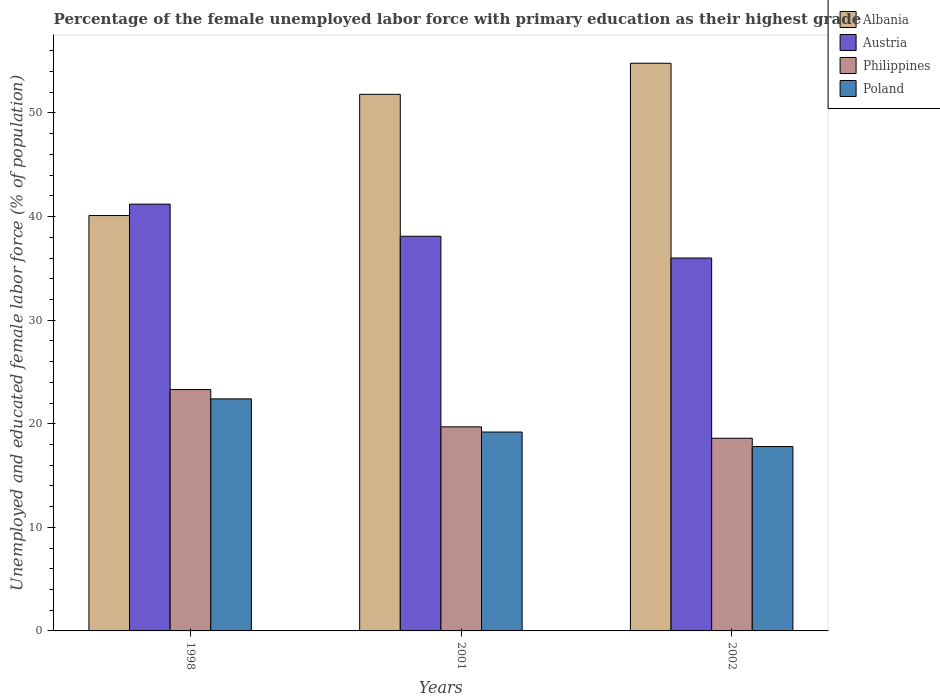How many different coloured bars are there?
Offer a very short reply. 4. How many bars are there on the 2nd tick from the left?
Provide a short and direct response. 4. How many bars are there on the 2nd tick from the right?
Provide a succinct answer. 4. In how many cases, is the number of bars for a given year not equal to the number of legend labels?
Ensure brevity in your answer.  0. What is the percentage of the unemployed female labor force with primary education in Poland in 1998?
Provide a short and direct response. 22.4. Across all years, what is the maximum percentage of the unemployed female labor force with primary education in Philippines?
Your answer should be compact. 23.3. Across all years, what is the minimum percentage of the unemployed female labor force with primary education in Philippines?
Provide a short and direct response. 18.6. In which year was the percentage of the unemployed female labor force with primary education in Albania minimum?
Provide a succinct answer. 1998. What is the total percentage of the unemployed female labor force with primary education in Austria in the graph?
Keep it short and to the point. 115.3. What is the difference between the percentage of the unemployed female labor force with primary education in Philippines in 1998 and that in 2002?
Ensure brevity in your answer.  4.7. What is the difference between the percentage of the unemployed female labor force with primary education in Philippines in 1998 and the percentage of the unemployed female labor force with primary education in Albania in 2001?
Keep it short and to the point. -28.5. What is the average percentage of the unemployed female labor force with primary education in Albania per year?
Ensure brevity in your answer.  48.9. In the year 2001, what is the difference between the percentage of the unemployed female labor force with primary education in Albania and percentage of the unemployed female labor force with primary education in Philippines?
Offer a terse response. 32.1. In how many years, is the percentage of the unemployed female labor force with primary education in Austria greater than 6 %?
Provide a short and direct response. 3. What is the ratio of the percentage of the unemployed female labor force with primary education in Albania in 1998 to that in 2002?
Keep it short and to the point. 0.73. What is the difference between the highest and the second highest percentage of the unemployed female labor force with primary education in Albania?
Give a very brief answer. 3. What is the difference between the highest and the lowest percentage of the unemployed female labor force with primary education in Philippines?
Provide a succinct answer. 4.7. Is the sum of the percentage of the unemployed female labor force with primary education in Albania in 1998 and 2002 greater than the maximum percentage of the unemployed female labor force with primary education in Poland across all years?
Give a very brief answer. Yes. Is it the case that in every year, the sum of the percentage of the unemployed female labor force with primary education in Poland and percentage of the unemployed female labor force with primary education in Albania is greater than the sum of percentage of the unemployed female labor force with primary education in Austria and percentage of the unemployed female labor force with primary education in Philippines?
Provide a succinct answer. Yes. What does the 1st bar from the left in 1998 represents?
Your answer should be compact. Albania. What does the 2nd bar from the right in 2001 represents?
Provide a short and direct response. Philippines. How many bars are there?
Keep it short and to the point. 12. How many years are there in the graph?
Offer a terse response. 3. Does the graph contain grids?
Your response must be concise. No. Where does the legend appear in the graph?
Your answer should be compact. Top right. What is the title of the graph?
Provide a succinct answer. Percentage of the female unemployed labor force with primary education as their highest grade. Does "Peru" appear as one of the legend labels in the graph?
Your answer should be compact. No. What is the label or title of the X-axis?
Your answer should be very brief. Years. What is the label or title of the Y-axis?
Your answer should be very brief. Unemployed and educated female labor force (% of population). What is the Unemployed and educated female labor force (% of population) of Albania in 1998?
Provide a short and direct response. 40.1. What is the Unemployed and educated female labor force (% of population) of Austria in 1998?
Make the answer very short. 41.2. What is the Unemployed and educated female labor force (% of population) in Philippines in 1998?
Your answer should be compact. 23.3. What is the Unemployed and educated female labor force (% of population) in Poland in 1998?
Offer a very short reply. 22.4. What is the Unemployed and educated female labor force (% of population) of Albania in 2001?
Make the answer very short. 51.8. What is the Unemployed and educated female labor force (% of population) in Austria in 2001?
Keep it short and to the point. 38.1. What is the Unemployed and educated female labor force (% of population) in Philippines in 2001?
Offer a terse response. 19.7. What is the Unemployed and educated female labor force (% of population) in Poland in 2001?
Offer a terse response. 19.2. What is the Unemployed and educated female labor force (% of population) of Albania in 2002?
Ensure brevity in your answer.  54.8. What is the Unemployed and educated female labor force (% of population) of Austria in 2002?
Offer a terse response. 36. What is the Unemployed and educated female labor force (% of population) of Philippines in 2002?
Your answer should be very brief. 18.6. What is the Unemployed and educated female labor force (% of population) of Poland in 2002?
Keep it short and to the point. 17.8. Across all years, what is the maximum Unemployed and educated female labor force (% of population) in Albania?
Your response must be concise. 54.8. Across all years, what is the maximum Unemployed and educated female labor force (% of population) of Austria?
Ensure brevity in your answer.  41.2. Across all years, what is the maximum Unemployed and educated female labor force (% of population) of Philippines?
Provide a succinct answer. 23.3. Across all years, what is the maximum Unemployed and educated female labor force (% of population) of Poland?
Offer a very short reply. 22.4. Across all years, what is the minimum Unemployed and educated female labor force (% of population) of Albania?
Keep it short and to the point. 40.1. Across all years, what is the minimum Unemployed and educated female labor force (% of population) of Philippines?
Give a very brief answer. 18.6. Across all years, what is the minimum Unemployed and educated female labor force (% of population) in Poland?
Keep it short and to the point. 17.8. What is the total Unemployed and educated female labor force (% of population) of Albania in the graph?
Your answer should be compact. 146.7. What is the total Unemployed and educated female labor force (% of population) of Austria in the graph?
Provide a succinct answer. 115.3. What is the total Unemployed and educated female labor force (% of population) in Philippines in the graph?
Your answer should be compact. 61.6. What is the total Unemployed and educated female labor force (% of population) of Poland in the graph?
Your answer should be compact. 59.4. What is the difference between the Unemployed and educated female labor force (% of population) of Albania in 1998 and that in 2001?
Offer a very short reply. -11.7. What is the difference between the Unemployed and educated female labor force (% of population) in Austria in 1998 and that in 2001?
Offer a very short reply. 3.1. What is the difference between the Unemployed and educated female labor force (% of population) of Philippines in 1998 and that in 2001?
Offer a terse response. 3.6. What is the difference between the Unemployed and educated female labor force (% of population) of Albania in 1998 and that in 2002?
Make the answer very short. -14.7. What is the difference between the Unemployed and educated female labor force (% of population) in Philippines in 1998 and that in 2002?
Offer a very short reply. 4.7. What is the difference between the Unemployed and educated female labor force (% of population) in Poland in 1998 and that in 2002?
Your answer should be very brief. 4.6. What is the difference between the Unemployed and educated female labor force (% of population) of Austria in 2001 and that in 2002?
Make the answer very short. 2.1. What is the difference between the Unemployed and educated female labor force (% of population) of Poland in 2001 and that in 2002?
Provide a short and direct response. 1.4. What is the difference between the Unemployed and educated female labor force (% of population) of Albania in 1998 and the Unemployed and educated female labor force (% of population) of Austria in 2001?
Provide a short and direct response. 2. What is the difference between the Unemployed and educated female labor force (% of population) of Albania in 1998 and the Unemployed and educated female labor force (% of population) of Philippines in 2001?
Keep it short and to the point. 20.4. What is the difference between the Unemployed and educated female labor force (% of population) of Albania in 1998 and the Unemployed and educated female labor force (% of population) of Poland in 2001?
Your answer should be very brief. 20.9. What is the difference between the Unemployed and educated female labor force (% of population) of Austria in 1998 and the Unemployed and educated female labor force (% of population) of Philippines in 2001?
Provide a succinct answer. 21.5. What is the difference between the Unemployed and educated female labor force (% of population) in Albania in 1998 and the Unemployed and educated female labor force (% of population) in Philippines in 2002?
Make the answer very short. 21.5. What is the difference between the Unemployed and educated female labor force (% of population) of Albania in 1998 and the Unemployed and educated female labor force (% of population) of Poland in 2002?
Keep it short and to the point. 22.3. What is the difference between the Unemployed and educated female labor force (% of population) of Austria in 1998 and the Unemployed and educated female labor force (% of population) of Philippines in 2002?
Your response must be concise. 22.6. What is the difference between the Unemployed and educated female labor force (% of population) in Austria in 1998 and the Unemployed and educated female labor force (% of population) in Poland in 2002?
Keep it short and to the point. 23.4. What is the difference between the Unemployed and educated female labor force (% of population) in Philippines in 1998 and the Unemployed and educated female labor force (% of population) in Poland in 2002?
Your answer should be very brief. 5.5. What is the difference between the Unemployed and educated female labor force (% of population) of Albania in 2001 and the Unemployed and educated female labor force (% of population) of Philippines in 2002?
Keep it short and to the point. 33.2. What is the difference between the Unemployed and educated female labor force (% of population) in Albania in 2001 and the Unemployed and educated female labor force (% of population) in Poland in 2002?
Offer a very short reply. 34. What is the difference between the Unemployed and educated female labor force (% of population) of Austria in 2001 and the Unemployed and educated female labor force (% of population) of Poland in 2002?
Provide a succinct answer. 20.3. What is the difference between the Unemployed and educated female labor force (% of population) of Philippines in 2001 and the Unemployed and educated female labor force (% of population) of Poland in 2002?
Make the answer very short. 1.9. What is the average Unemployed and educated female labor force (% of population) of Albania per year?
Keep it short and to the point. 48.9. What is the average Unemployed and educated female labor force (% of population) of Austria per year?
Keep it short and to the point. 38.43. What is the average Unemployed and educated female labor force (% of population) in Philippines per year?
Your response must be concise. 20.53. What is the average Unemployed and educated female labor force (% of population) of Poland per year?
Provide a short and direct response. 19.8. In the year 1998, what is the difference between the Unemployed and educated female labor force (% of population) in Albania and Unemployed and educated female labor force (% of population) in Philippines?
Ensure brevity in your answer.  16.8. In the year 1998, what is the difference between the Unemployed and educated female labor force (% of population) in Albania and Unemployed and educated female labor force (% of population) in Poland?
Your response must be concise. 17.7. In the year 1998, what is the difference between the Unemployed and educated female labor force (% of population) of Austria and Unemployed and educated female labor force (% of population) of Philippines?
Give a very brief answer. 17.9. In the year 1998, what is the difference between the Unemployed and educated female labor force (% of population) of Philippines and Unemployed and educated female labor force (% of population) of Poland?
Your response must be concise. 0.9. In the year 2001, what is the difference between the Unemployed and educated female labor force (% of population) in Albania and Unemployed and educated female labor force (% of population) in Austria?
Your response must be concise. 13.7. In the year 2001, what is the difference between the Unemployed and educated female labor force (% of population) of Albania and Unemployed and educated female labor force (% of population) of Philippines?
Provide a succinct answer. 32.1. In the year 2001, what is the difference between the Unemployed and educated female labor force (% of population) in Albania and Unemployed and educated female labor force (% of population) in Poland?
Your response must be concise. 32.6. In the year 2001, what is the difference between the Unemployed and educated female labor force (% of population) of Philippines and Unemployed and educated female labor force (% of population) of Poland?
Provide a succinct answer. 0.5. In the year 2002, what is the difference between the Unemployed and educated female labor force (% of population) of Albania and Unemployed and educated female labor force (% of population) of Austria?
Your answer should be very brief. 18.8. In the year 2002, what is the difference between the Unemployed and educated female labor force (% of population) of Albania and Unemployed and educated female labor force (% of population) of Philippines?
Ensure brevity in your answer.  36.2. In the year 2002, what is the difference between the Unemployed and educated female labor force (% of population) in Austria and Unemployed and educated female labor force (% of population) in Philippines?
Your answer should be very brief. 17.4. In the year 2002, what is the difference between the Unemployed and educated female labor force (% of population) in Philippines and Unemployed and educated female labor force (% of population) in Poland?
Keep it short and to the point. 0.8. What is the ratio of the Unemployed and educated female labor force (% of population) in Albania in 1998 to that in 2001?
Offer a terse response. 0.77. What is the ratio of the Unemployed and educated female labor force (% of population) in Austria in 1998 to that in 2001?
Provide a short and direct response. 1.08. What is the ratio of the Unemployed and educated female labor force (% of population) of Philippines in 1998 to that in 2001?
Provide a short and direct response. 1.18. What is the ratio of the Unemployed and educated female labor force (% of population) in Albania in 1998 to that in 2002?
Ensure brevity in your answer.  0.73. What is the ratio of the Unemployed and educated female labor force (% of population) of Austria in 1998 to that in 2002?
Make the answer very short. 1.14. What is the ratio of the Unemployed and educated female labor force (% of population) of Philippines in 1998 to that in 2002?
Your answer should be compact. 1.25. What is the ratio of the Unemployed and educated female labor force (% of population) in Poland in 1998 to that in 2002?
Your response must be concise. 1.26. What is the ratio of the Unemployed and educated female labor force (% of population) in Albania in 2001 to that in 2002?
Provide a short and direct response. 0.95. What is the ratio of the Unemployed and educated female labor force (% of population) in Austria in 2001 to that in 2002?
Provide a short and direct response. 1.06. What is the ratio of the Unemployed and educated female labor force (% of population) of Philippines in 2001 to that in 2002?
Offer a terse response. 1.06. What is the ratio of the Unemployed and educated female labor force (% of population) of Poland in 2001 to that in 2002?
Make the answer very short. 1.08. What is the difference between the highest and the second highest Unemployed and educated female labor force (% of population) in Albania?
Keep it short and to the point. 3. What is the difference between the highest and the second highest Unemployed and educated female labor force (% of population) in Austria?
Your answer should be very brief. 3.1. What is the difference between the highest and the second highest Unemployed and educated female labor force (% of population) in Philippines?
Offer a terse response. 3.6. What is the difference between the highest and the second highest Unemployed and educated female labor force (% of population) of Poland?
Give a very brief answer. 3.2. What is the difference between the highest and the lowest Unemployed and educated female labor force (% of population) of Austria?
Ensure brevity in your answer.  5.2. What is the difference between the highest and the lowest Unemployed and educated female labor force (% of population) of Philippines?
Offer a very short reply. 4.7. What is the difference between the highest and the lowest Unemployed and educated female labor force (% of population) of Poland?
Offer a very short reply. 4.6. 